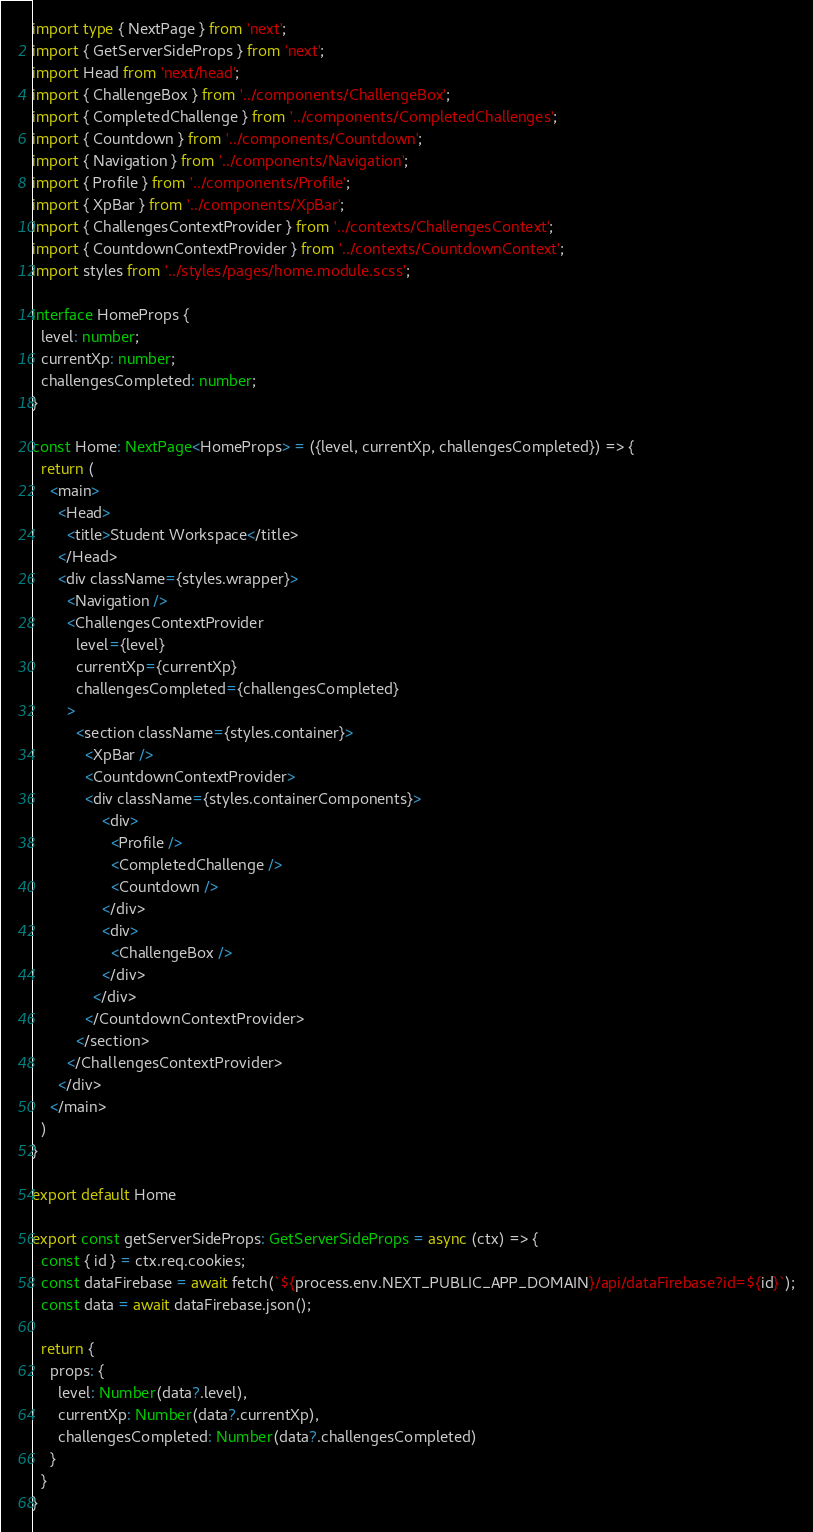<code> <loc_0><loc_0><loc_500><loc_500><_TypeScript_>import type { NextPage } from 'next';
import { GetServerSideProps } from 'next';
import Head from 'next/head';
import { ChallengeBox } from '../components/ChallengeBox';
import { CompletedChallenge } from '../components/CompletedChallenges';
import { Countdown } from '../components/Countdown';
import { Navigation } from '../components/Navigation';
import { Profile } from '../components/Profile';
import { XpBar } from '../components/XpBar';
import { ChallengesContextProvider } from '../contexts/ChallengesContext';
import { CountdownContextProvider } from '../contexts/CountdownContext';
import styles from '../styles/pages/home.module.scss';

interface HomeProps {
  level: number;
  currentXp: number;
  challengesCompleted: number;
}

const Home: NextPage<HomeProps> = ({level, currentXp, challengesCompleted}) => {
  return (
    <main>
      <Head>
        <title>Student Workspace</title>
      </Head>
      <div className={styles.wrapper}>
        <Navigation />
        <ChallengesContextProvider
          level={level}
          currentXp={currentXp}
          challengesCompleted={challengesCompleted}
        >
          <section className={styles.container}>
            <XpBar />
            <CountdownContextProvider>
            <div className={styles.containerComponents}>
                <div>
                  <Profile />
                  <CompletedChallenge />
                  <Countdown />
                </div>
                <div>
                  <ChallengeBox />
                </div>
              </div>
            </CountdownContextProvider>
          </section>
        </ChallengesContextProvider>
      </div>
    </main>
  )
}

export default Home

export const getServerSideProps: GetServerSideProps = async (ctx) => {
  const { id } = ctx.req.cookies;
  const dataFirebase = await fetch(`${process.env.NEXT_PUBLIC_APP_DOMAIN}/api/dataFirebase?id=${id}`);
  const data = await dataFirebase.json();

  return {
    props: {
      level: Number(data?.level),
      currentXp: Number(data?.currentXp),
      challengesCompleted: Number(data?.challengesCompleted)
    }
  }
}
</code> 